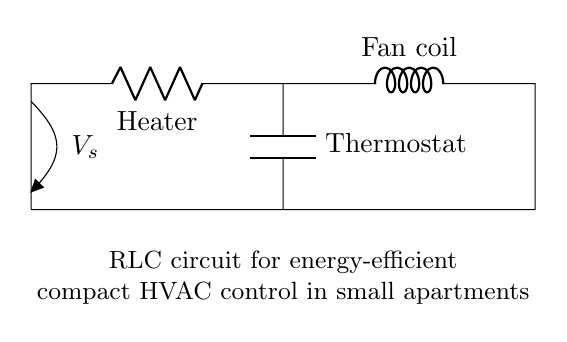What components are in this circuit? The circuit includes a resistor, an inductor, and a capacitor, labeled as R, L, and C respectively.
Answer: Resistor, Inductor, Capacitor What is the purpose of the resistor in this circuit? The resistor, identified as the heater, is likely used to limit current flow and convert electrical energy into heat, aiding in temperature control.
Answer: Current limiting What does the inductor represent in this circuit? The inductor, labeled as the fan coil, stores energy in a magnetic field when current passes through it, contributing to the HVAC function.
Answer: Energy storage How many main components can be identified in this circuit? The circuit has three main components: a resistor, an inductor, and a capacitor.
Answer: Three What does the symbol V_s represent in this circuit? The symbol V_s denotes the supply voltage, indicating the electrical potential provided to the circuit.
Answer: Supply voltage How does the thermostat function within this RLC circuit? The thermostat, represented by the capacitor, helps regulate the energy flow by storing and releasing charge based on temperature control, contributing to energy efficiency.
Answer: Energy regulation 